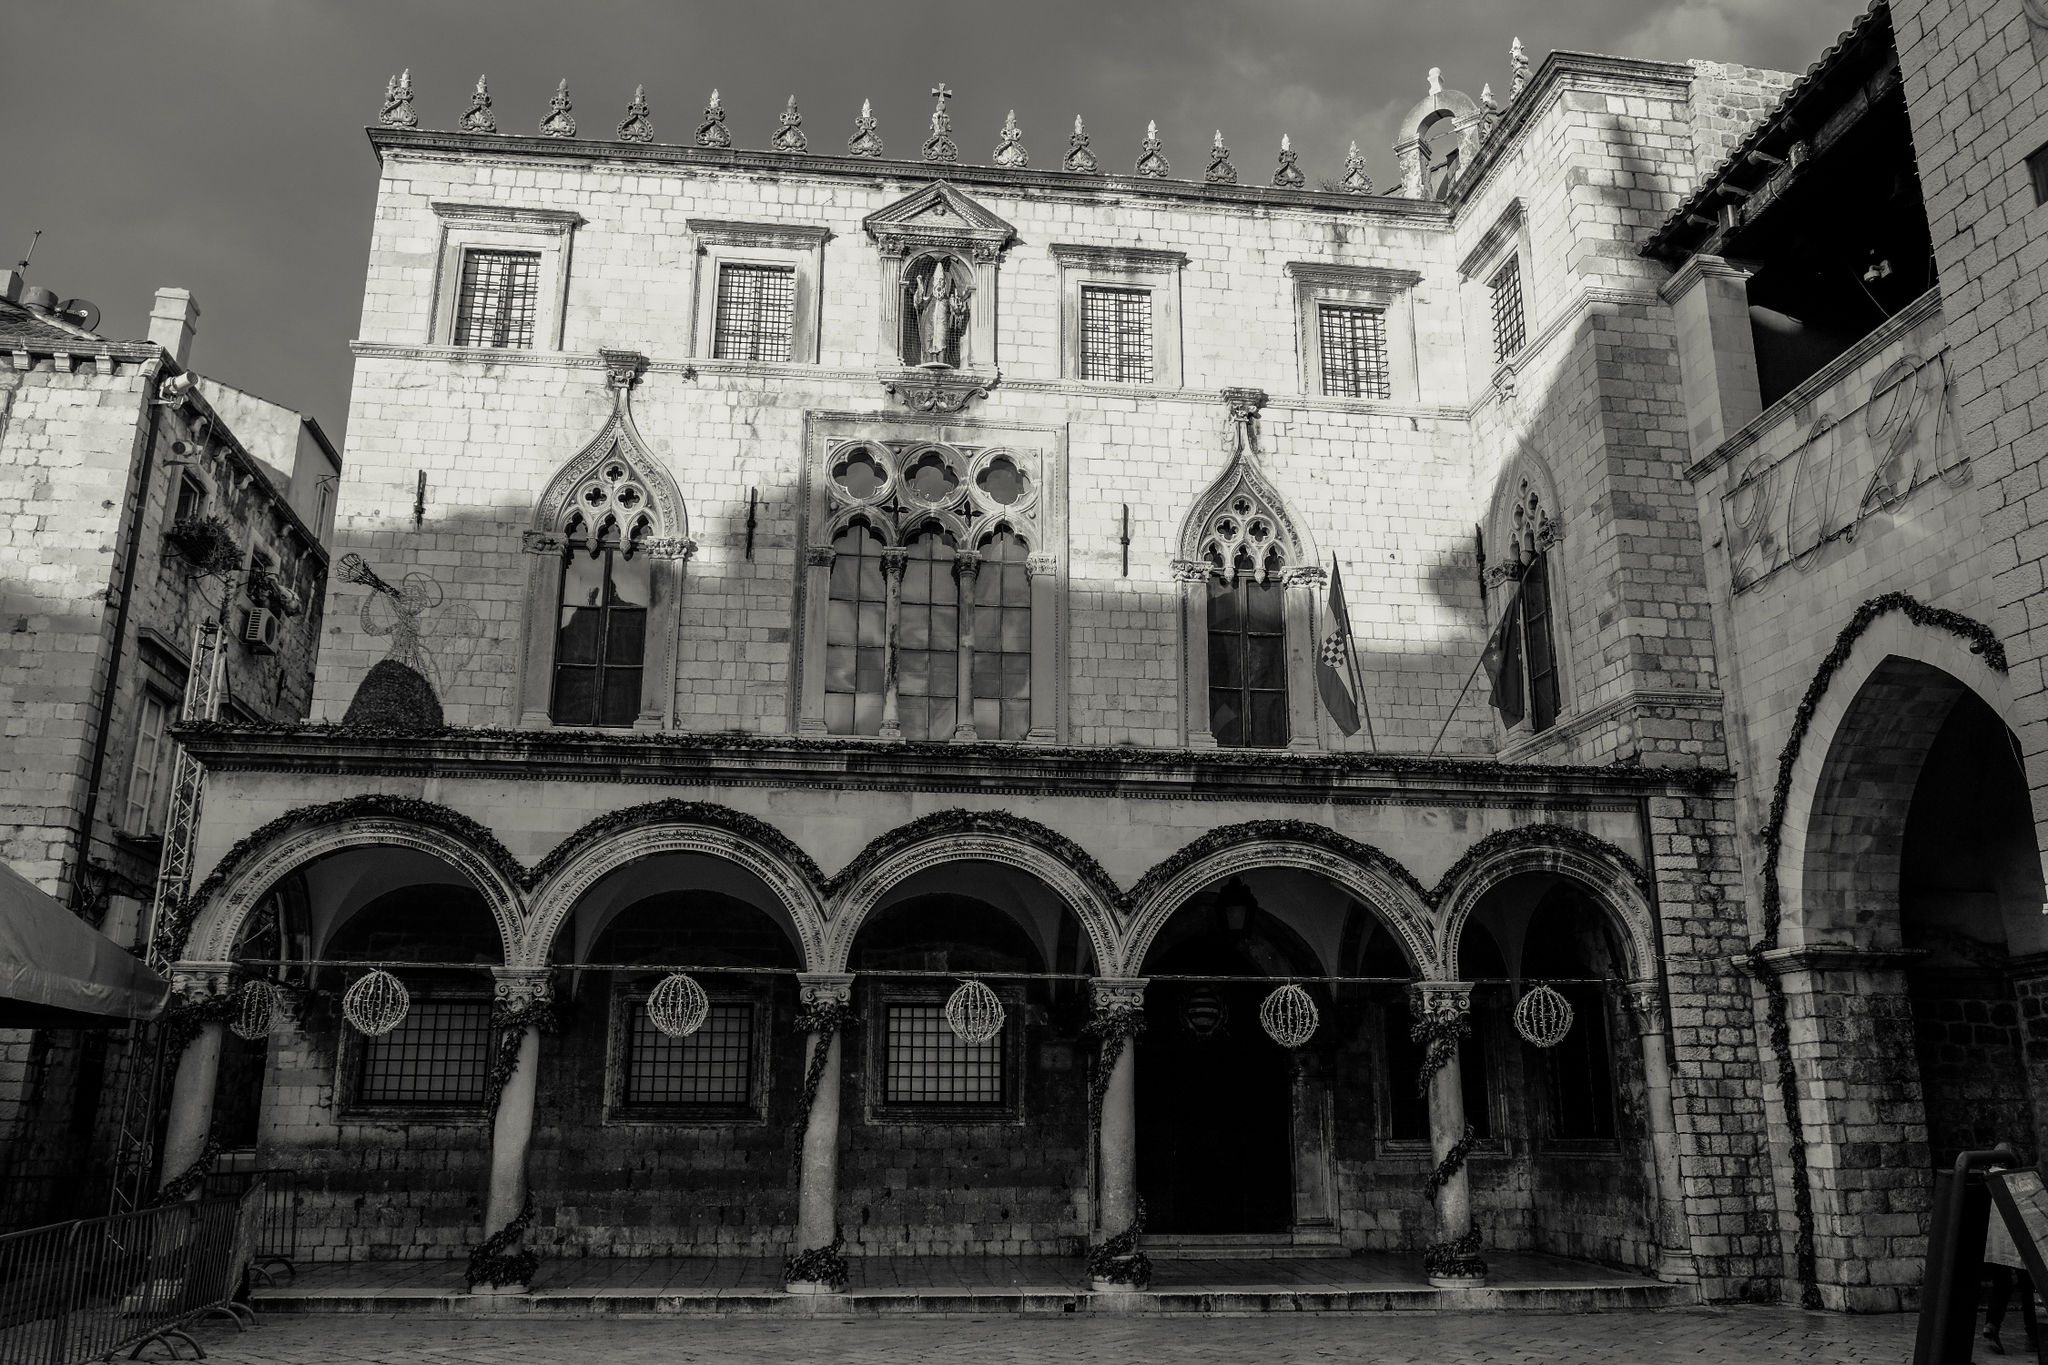What do you see happening in this image? This image captures the magnificent architecture of a historic building, identified as the Rector's Palace in Dubrovnik, Croatia. The palace, built in a stunning Gothic-Renaissance style, stands with a grand stone facade featuring elaborate arched windows and intricate architectural details. The black and white color scheme accentuates the texture of the stone, emphasizing the historic and majestic feel of the structure. The photo is taken from a low angle, making the palace appear even more imposing, with shadows cast on one side, creating a dramatic contrast. The sky above is partly cloudy, adding to the serene yet grand atmosphere of the scene. The overall view highlights the rich cultural heritage and architectural expertise of Dubrovnik. 